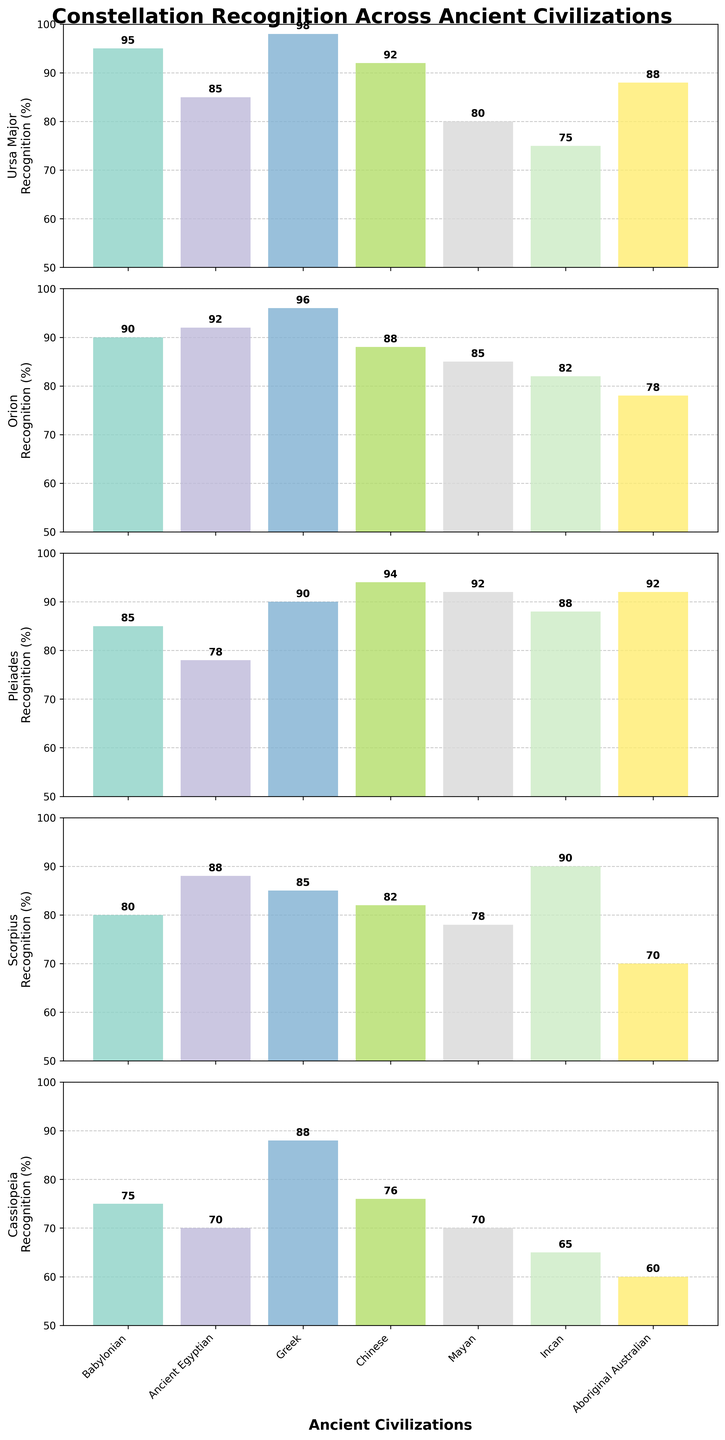What is the title of the figure? The title of the figure is located at the top and reads "Constellation Recognition Across Ancient Civilizations" in bold. This can be visually verified by looking at the top center of the figure.
Answer: Constellation Recognition Across Ancient Civilizations Which civilization shows the lowest recognition for Cassiopeia? To find the lowest recognition for Cassiopeia, look at the data for each civilization under the Cassiopeia subplot (the last subplot). The Incan civilization has the lowest recognition percentage at 65.
Answer: Incan Which constellation has the highest average recognition across all civilizations? Calculate the average recognition for each constellation by summing their recognition percentages across all civilizations and then dividing by the number of civilizations (7). Ursa Major: (95 + 85 + 98 + 92 + 80 + 75 + 88) / 7 = 87.57, Orion: (90 + 92 + 96 + 88 + 85 + 82 + 78) / 7 = 87.29, Pleiades: (85 + 78 + 90 + 94 + 92 + 88 + 92) / 7 = 88.43, Scorpius: (80 + 88 + 85 + 82 + 78 + 90 + 70) / 7 = 81.86, Cassiopeia: (75 + 70 + 88 + 76 + 70 + 65 + 60) / 7 = 72.00. The Pleiades has the highest average recognition.
Answer: Pleiades Which two civilizations have the most similar recognition patterns across all constellations? Compare the recognition percentages for each constellation across all civilizations and find the two sets that are closest. Notice that the Greek and Chinese civilizations have very similar recognition percentages: Greek (98, 96, 90, 85, 88) and Chinese (92, 88, 94, 82, 76). Calculating the differences for each constellation: Ursa Major (98-92=6), Orion (96-88=8), Pleiades (90-94=4), Scorpius (85-82=3), Cassiopeia (88-76=12). Summing the absolute differences: 6 + 8 + 4 + 3 + 12 = 33. They are the most similar overall.
Answer: Greek and Chinese How much higher is the recognition of Orion by the Greek civilization compared to the Aboriginal Australian civilization? Look at the Orion recognition percentages for the Greek and Aboriginal Australian civilizations, which are 96 and 78 respectively. Subtract the Aboriginal Australian percentage from the Greek percentage: 96 - 78 = 18.
Answer: 18 What is the median recognition value of Pleiades across all civilizations? To find the median, first list the recognition values for Pleiades: 85, 78, 90, 94, 92, 88, 92. Arrange these values in ascending order: 78, 85, 88, 90, 92, 92, 94. The middle value is 90.
Answer: 90 Which civilization has the most consistent recognition (smallest range) across all constellations? Calculate the range for each civilization by subtracting the minimum recognition value from the maximum recognition value for each civilization. Babylonian: 95-75=20, Ancient Egyptian: 92-70=22, Greek: 98-85=13, Chinese: 94-76=18, Mayan: 92-70=22, Incan: 90-65=25, Aboriginal Australian: 92-60=32. The Greek civilization has the smallest range at 13.
Answer: Greek What is the recognition percentage difference for Scorpius between the Incan and Babylonian civilizations? Look at the Scorpius recognition percentages for the Incan and Babylonian civilizations, which are 90 and 80 respectively. Subtract the Babylonian percentage from the Incan percentage: 90 - 80 = 10.
Answer: 10 